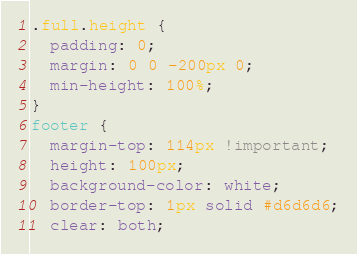Convert code to text. <code><loc_0><loc_0><loc_500><loc_500><_CSS_>.full.height {
  padding: 0;
  margin: 0 0 -200px 0;
  min-height: 100%;
}
footer {
  margin-top: 114px !important;
  height: 100px;
  background-color: white;
  border-top: 1px solid #d6d6d6;
  clear: both;</code> 